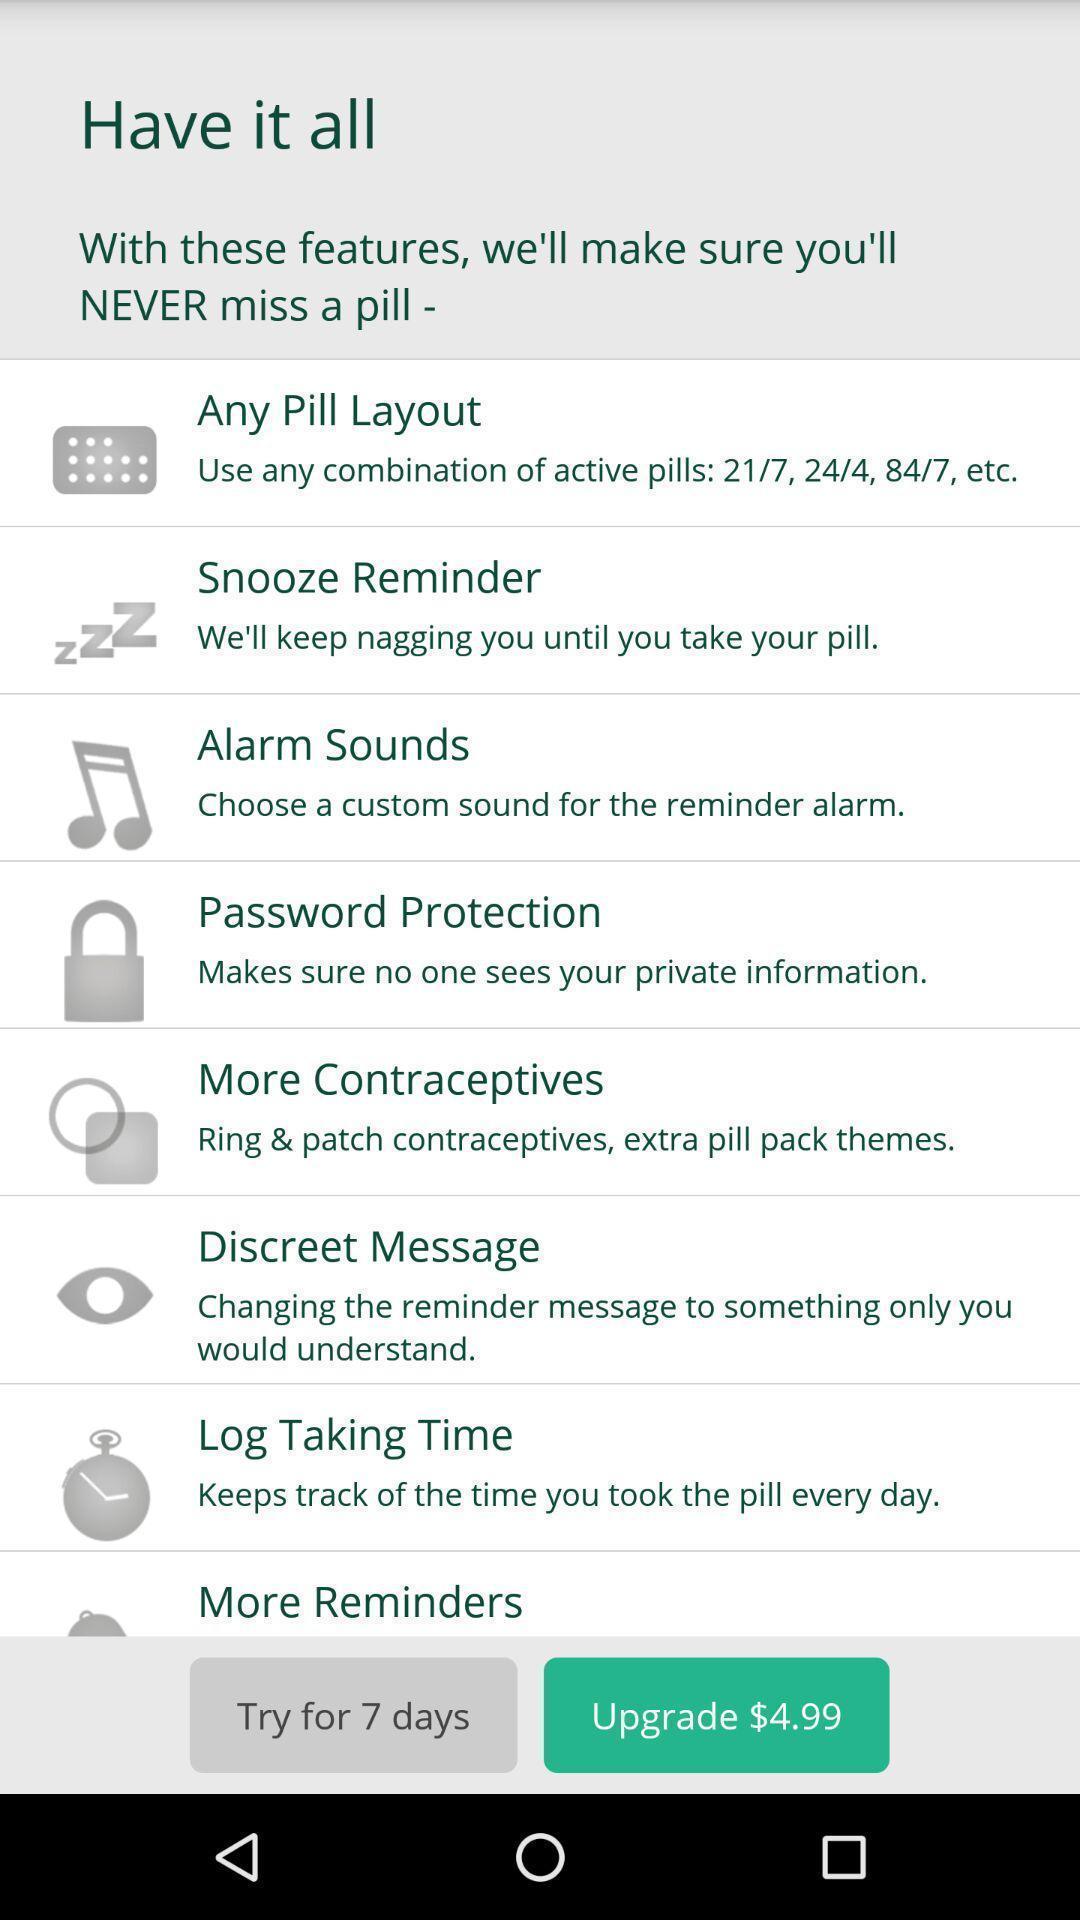Provide a textual representation of this image. Page displaying the multiple audio player options. 